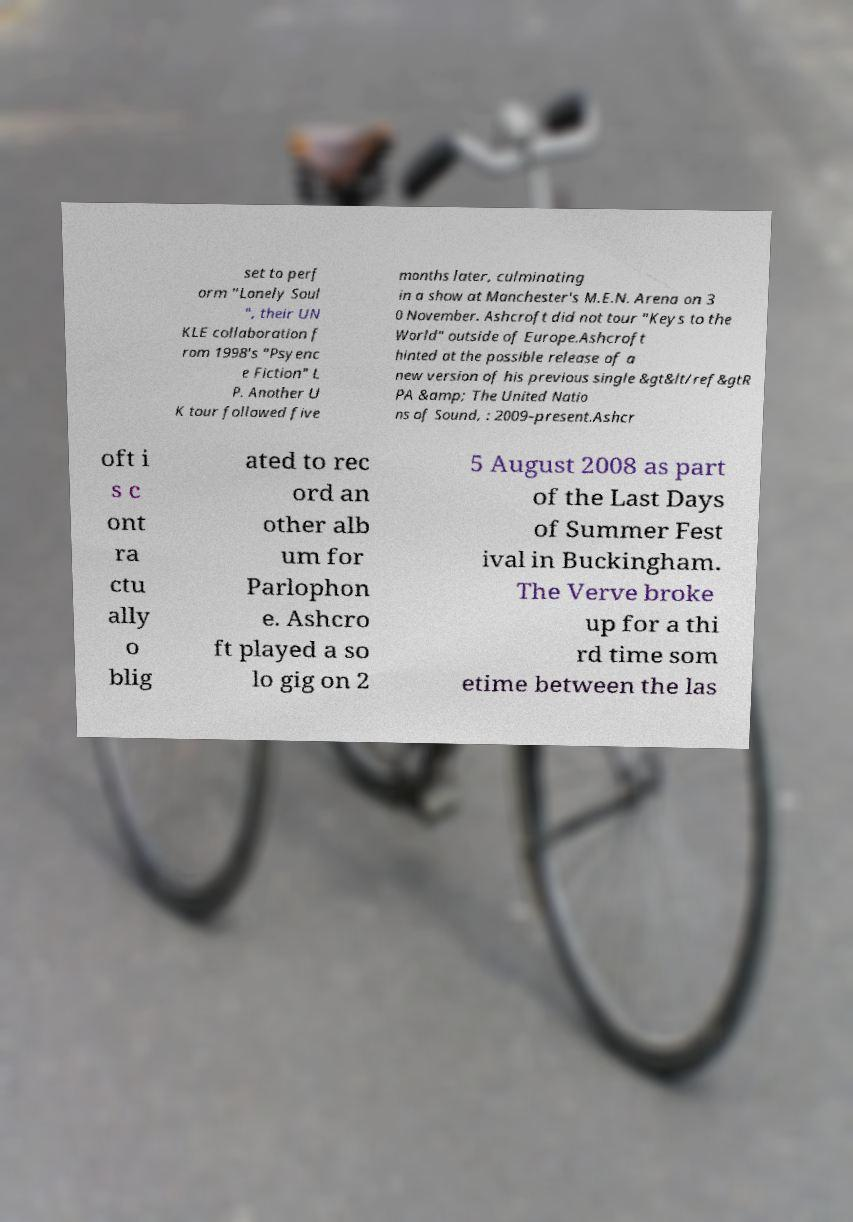What messages or text are displayed in this image? I need them in a readable, typed format. set to perf orm "Lonely Soul ", their UN KLE collaboration f rom 1998's "Psyenc e Fiction" L P. Another U K tour followed five months later, culminating in a show at Manchester's M.E.N. Arena on 3 0 November. Ashcroft did not tour "Keys to the World" outside of Europe.Ashcroft hinted at the possible release of a new version of his previous single &gt&lt/ref&gtR PA &amp; The United Natio ns of Sound, : 2009–present.Ashcr oft i s c ont ra ctu ally o blig ated to rec ord an other alb um for Parlophon e. Ashcro ft played a so lo gig on 2 5 August 2008 as part of the Last Days of Summer Fest ival in Buckingham. The Verve broke up for a thi rd time som etime between the las 